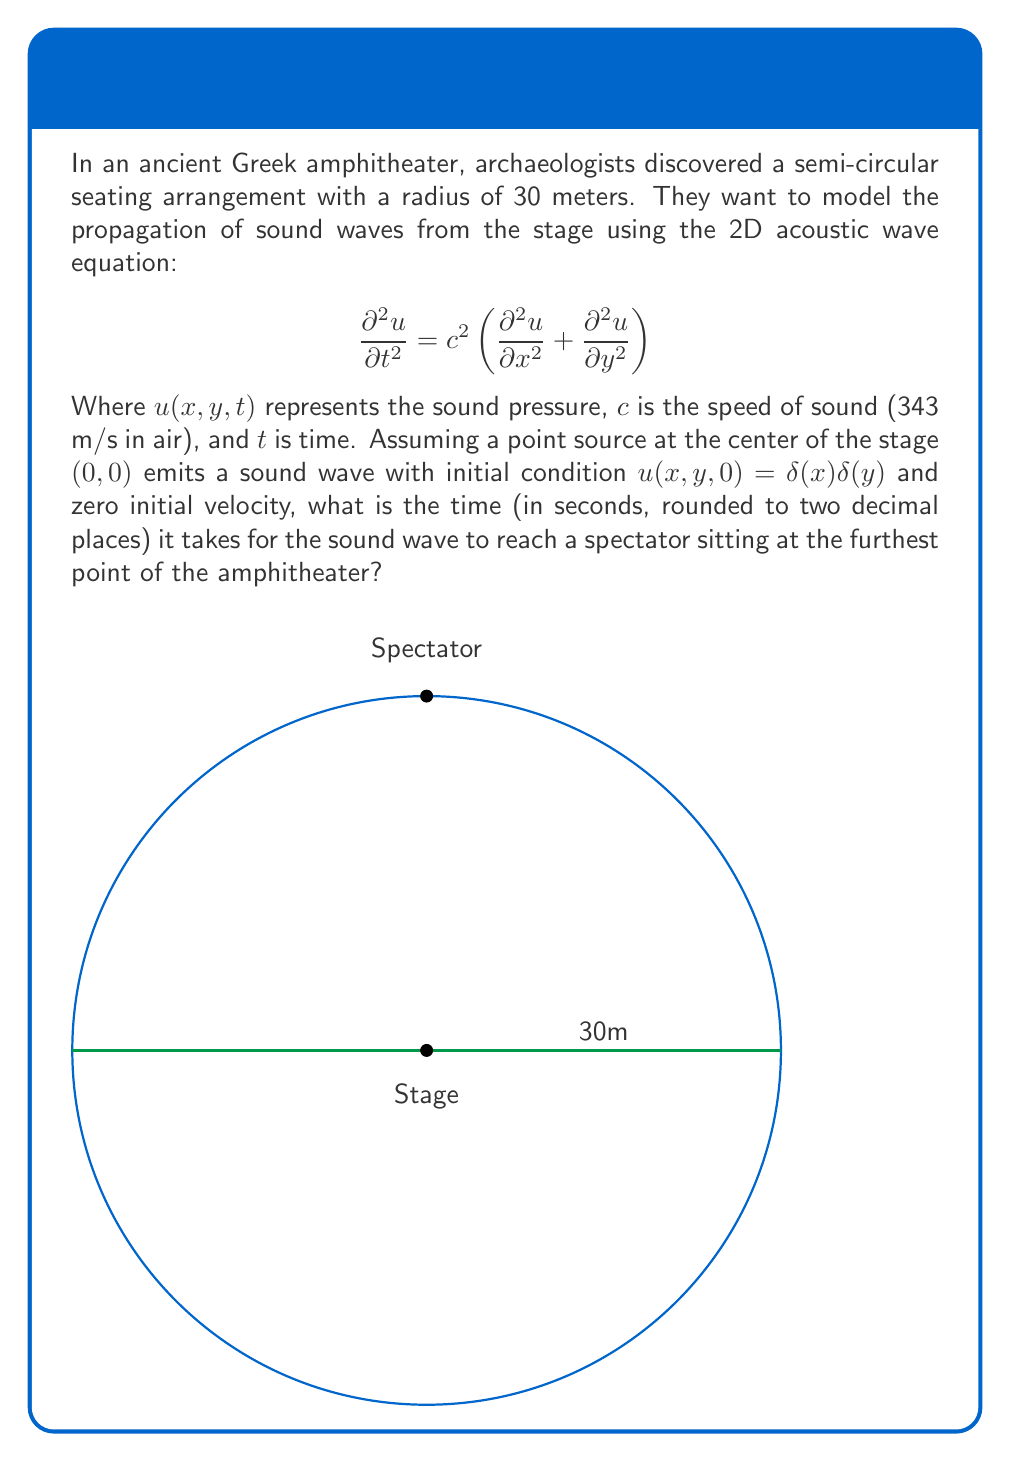Show me your answer to this math problem. To solve this problem, we need to follow these steps:

1) First, we need to identify the position of the furthest spectator. In a semi-circular arrangement, this would be at the point (0, 30) - directly opposite the stage across the diameter.

2) The distance between the sound source (0,0) and the spectator (0,30) is simply the radius of the amphitheater, which is 30 meters.

3) While the acoustic wave equation describes the propagation of the sound wave, for this simple case of finding the time to reach a specific point, we can use the basic formula:

   $$\text{Distance} = \text{Speed} \times \text{Time}$$

4) We know the distance (30 m) and the speed of sound (343 m/s). Let's call the time $t$. So we have:

   $$30 = 343t$$

5) Solving for $t$:

   $$t = \frac{30}{343} \approx 0.0875 \text{ seconds}$$

6) Rounding to two decimal places:

   $$t \approx 0.09 \text{ seconds}$$

This solution assumes ideal conditions and doesn't account for factors like air temperature, humidity, or the complex acoustics of the amphitheater structure. In reality, these factors would influence the wave propagation described by the full acoustic wave equation.
Answer: 0.09 seconds 